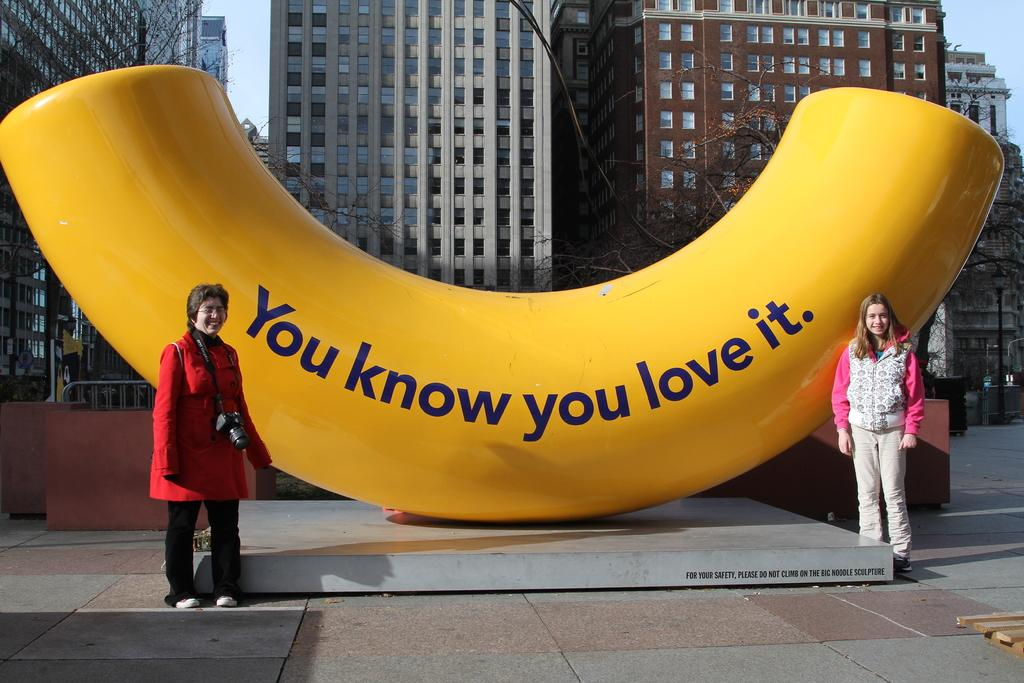How many women are in the image? There are two women in the image. What are the women doing in the image? The women are standing near an object. Can you describe the object the women are standing near? The object has text on it. What can be seen in the background of the image? There are trees, buildings, and the sky visible in the background of the image. What type of crime is being committed by the yak in the image? There is no yak present in the image, and therefore no crime can be committed by a yak. What is the women carrying in the image? The provided facts do not mention a bag or any item being carried by the women. 